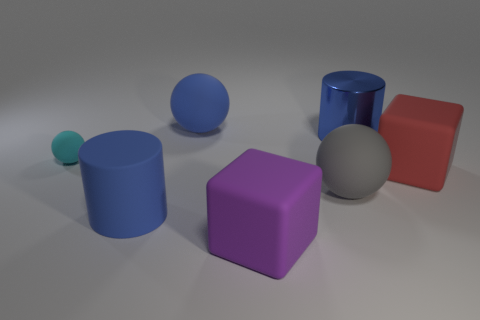Add 3 purple objects. How many objects exist? 10 Subtract all large balls. How many balls are left? 1 Subtract 1 spheres. How many spheres are left? 2 Subtract all gray spheres. How many spheres are left? 2 Subtract all cyan cubes. How many blue spheres are left? 1 Subtract all blue cylinders. Subtract all rubber cylinders. How many objects are left? 4 Add 3 large red cubes. How many large red cubes are left? 4 Add 2 purple cubes. How many purple cubes exist? 3 Subtract 1 cyan balls. How many objects are left? 6 Subtract all cubes. How many objects are left? 5 